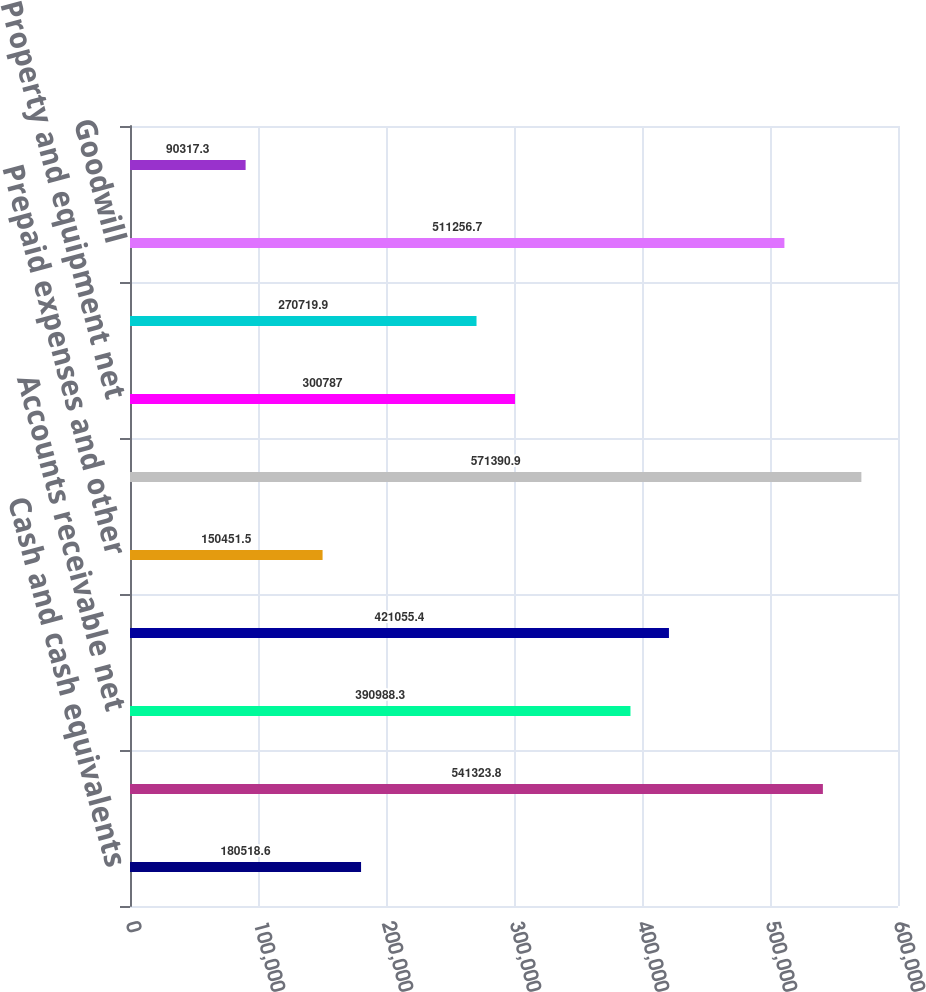<chart> <loc_0><loc_0><loc_500><loc_500><bar_chart><fcel>Cash and cash equivalents<fcel>Short-term marketable<fcel>Accounts receivable net<fcel>Inventories<fcel>Prepaid expenses and other<fcel>Total current assets<fcel>Property and equipment net<fcel>Intangible assets net<fcel>Goodwill<fcel>Other assets<nl><fcel>180519<fcel>541324<fcel>390988<fcel>421055<fcel>150452<fcel>571391<fcel>300787<fcel>270720<fcel>511257<fcel>90317.3<nl></chart> 